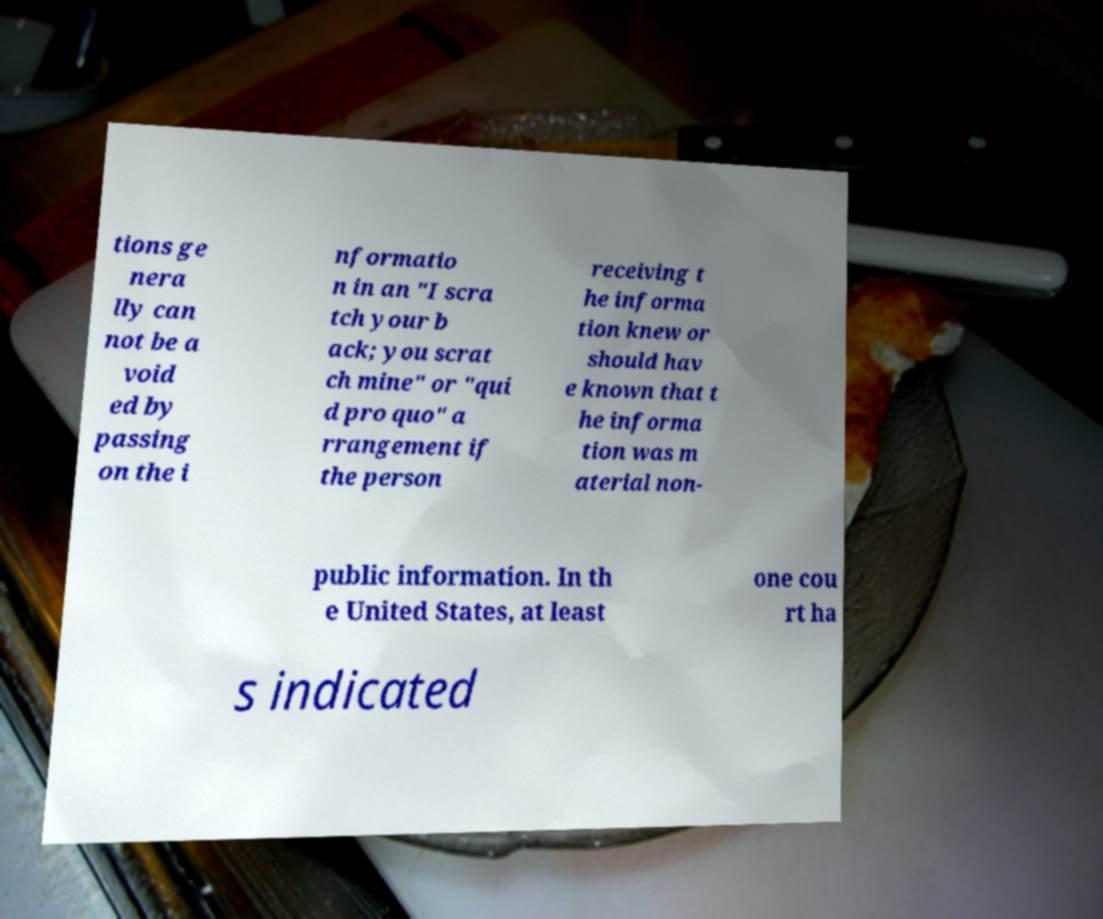For documentation purposes, I need the text within this image transcribed. Could you provide that? tions ge nera lly can not be a void ed by passing on the i nformatio n in an "I scra tch your b ack; you scrat ch mine" or "qui d pro quo" a rrangement if the person receiving t he informa tion knew or should hav e known that t he informa tion was m aterial non- public information. In th e United States, at least one cou rt ha s indicated 